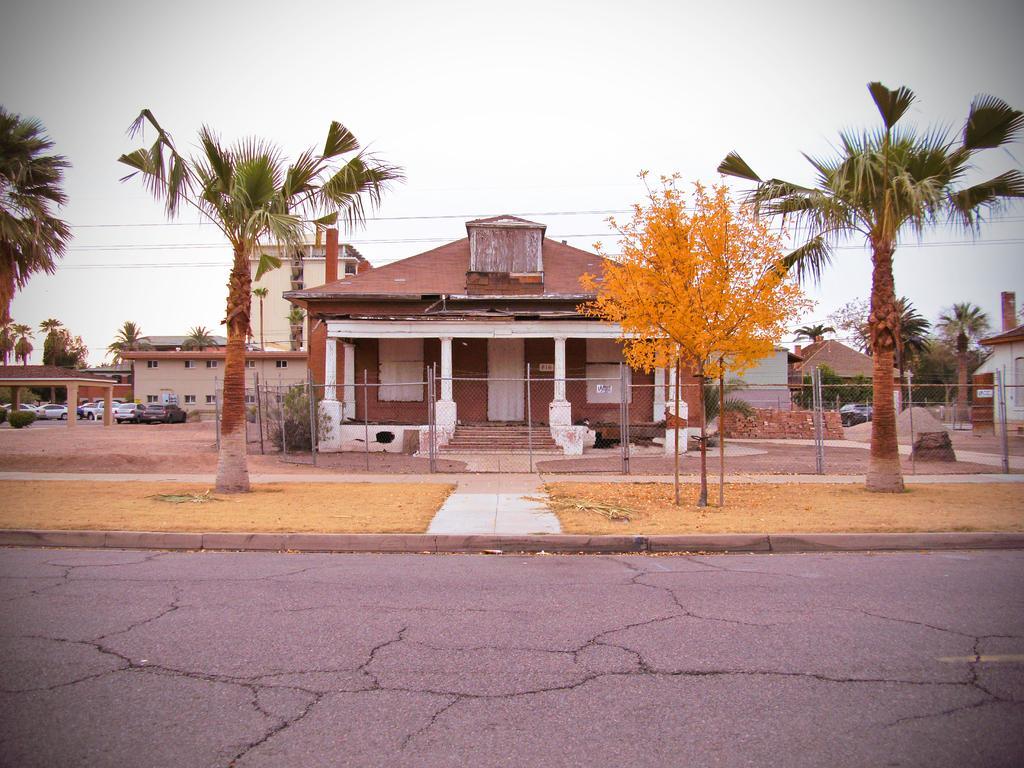Could you give a brief overview of what you see in this image? In the picture there is a road, there are many trees present, there is grass, there are houses, there are many vehicles present, there is an iron pole fence, there is a clear sky. 